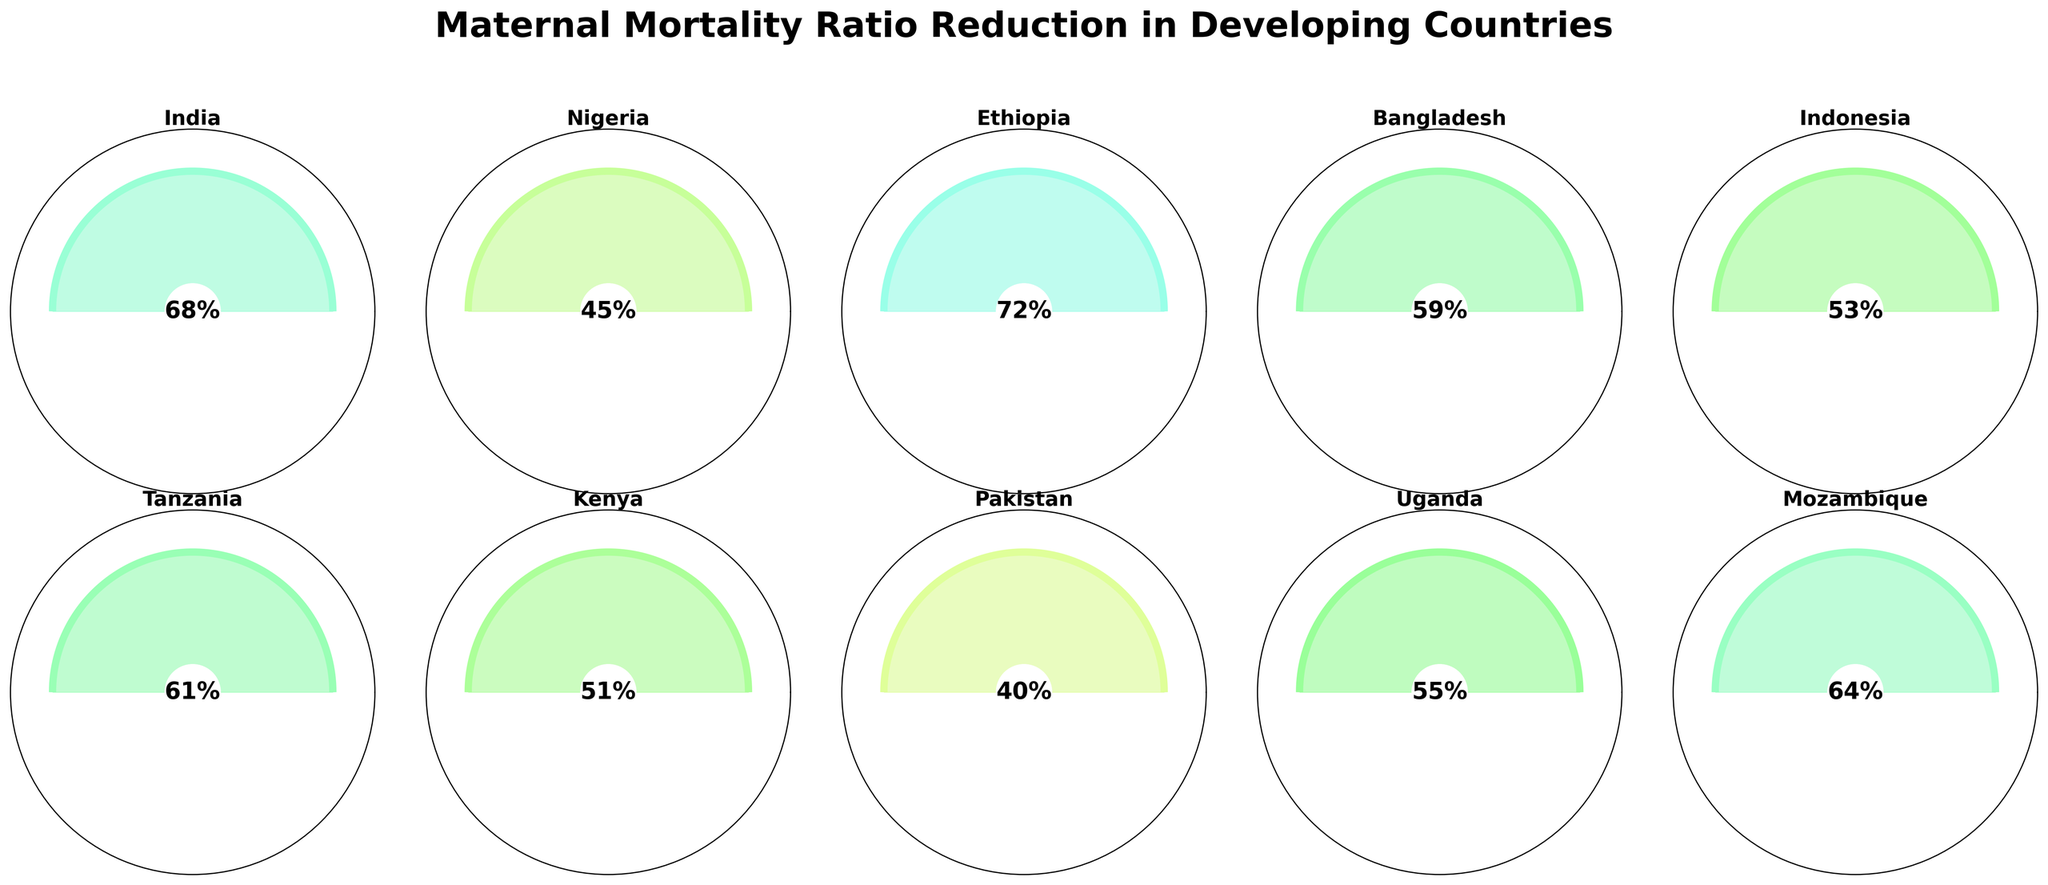What is the title of the figure? The title of the figure is at the top and provides a summary of the entire chart. The title reads "Maternal Mortality Ratio Reduction in Developing Countries".
Answer: Maternal Mortality Ratio Reduction in Developing Countries Which country has the highest reduction in maternal mortality ratio? Each gauge chart and its associated label show the reduction percentage for different countries. Ethiopia has the highest value of 72%.
Answer: Ethiopia What is the median reduction percentage of the countries shown? To find the median, list the percentages in order: 40, 45, 51, 53, 55, 59, 61, 64, 68, 72. The middle values are 55 and 59. The median is the average of these two values: (55 + 59) / 2 = 57.
Answer: 57 Which two countries have the closest reduction percentages? By examining the values, Kenya (51%) and Indonesia (53%) have the closest reduction percentages with a difference of just 2%.
Answer: Kenya and Indonesia How many countries have a reduction percentage greater than 60%? By scanning the gauge charts, the countries with reduction percentages greater than 60% are India (68%), Ethiopia (72%), Tanzania (61%), and Mozambique (64%). There are 4 such countries.
Answer: 4 Which country shows lower reduction, Pakistan or Uganda? By comparing the values shown in their respective gauge charts, Pakistan has 40% and Uganda has 55%, indicating Pakistan shows the lower reduction.
Answer: Pakistan What is the combined reduction percentage for Bangladesh and Nigeria? Bangladesh has a reduction percentage of 59% and Nigeria has 45%. Summing these values: 59 + 45 = 104.
Answer: 104 How does the reduction rate of Mozambique compare to that of Tanzania? Mozambique has a reduction percentage of 64% and Tanzania has 61%. Mozambique's reduction rate (64%) is higher than Tanzania's (61%).
Answer: Mozambique has a higher reduction rate What is the difference in reduction percentage between India and Pakistan? India has a reduction percentage of 68% and Pakistan has 40%. The difference is calculated as 68 - 40 = 28.
Answer: 28 Which country has the lowest reduction in maternal mortality ratio? Referring to the values in the gauge charts, Pakistan has the lowest reduction percentage at 40%.
Answer: Pakistan 